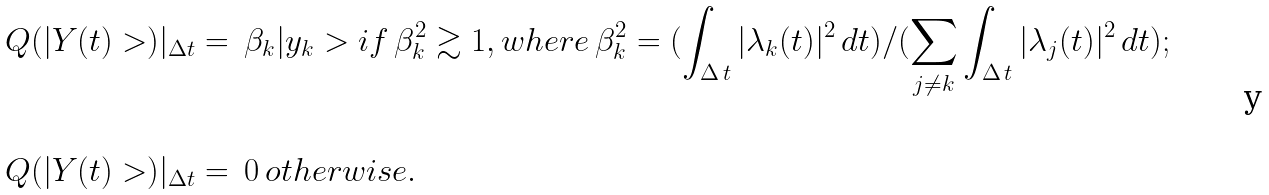Convert formula to latex. <formula><loc_0><loc_0><loc_500><loc_500>Q ( | Y ( t ) > ) | _ { \Delta t } & = \, \beta _ { k } | y _ { k } > i f \, \beta _ { k } ^ { 2 } \gtrsim 1 , w h e r e \, \beta _ { k } ^ { 2 } = ( \int _ { \Delta \, t } | \lambda _ { k } ( t ) | ^ { 2 } \, d t ) / ( \sum _ { j \neq k } \int _ { \Delta \, t } | \lambda _ { j } ( t ) | ^ { 2 } \, d t ) ; \\ \\ Q ( | Y ( t ) > ) | _ { \Delta t } & = \, 0 \, o t h e r w i s e .</formula> 